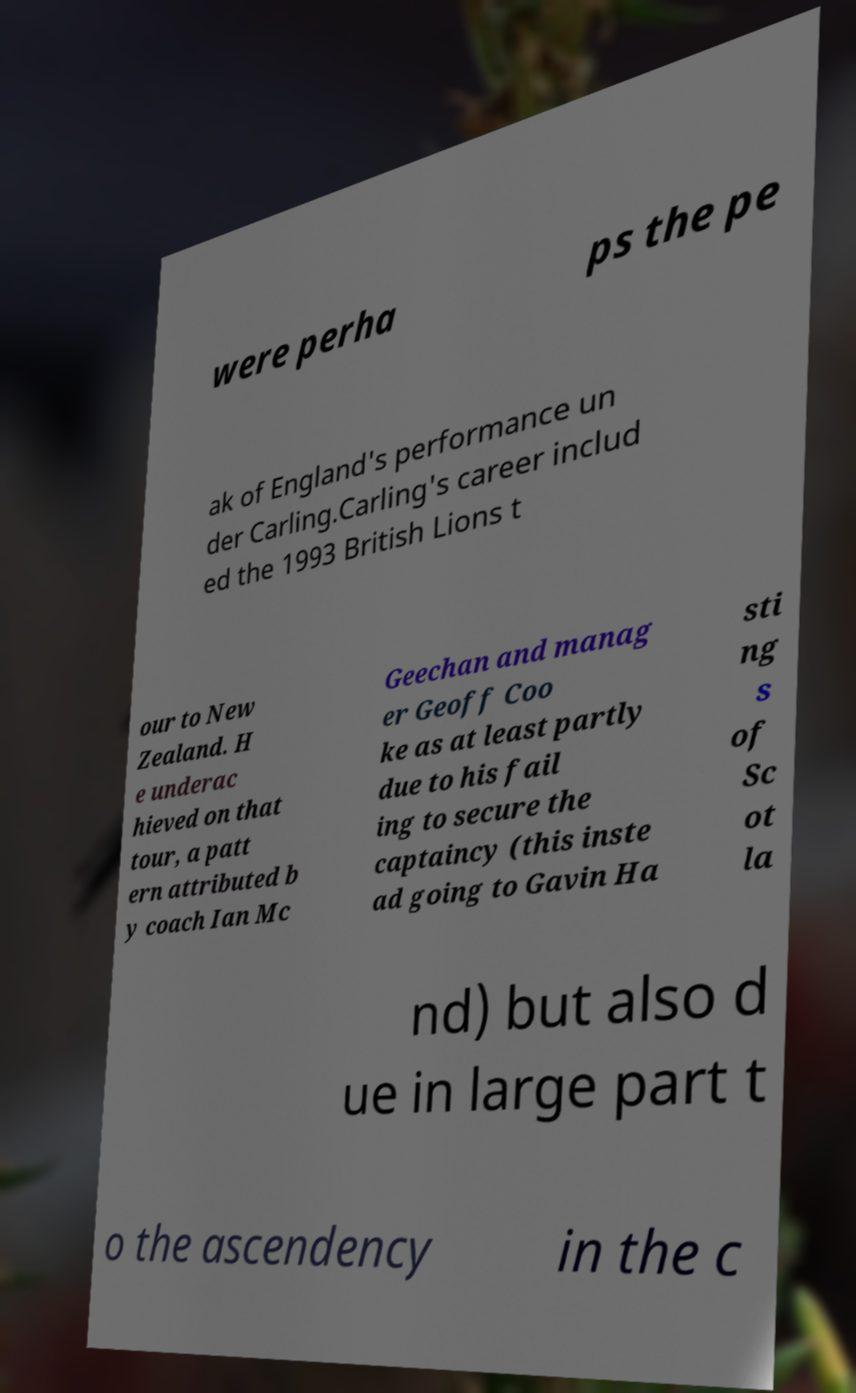For documentation purposes, I need the text within this image transcribed. Could you provide that? were perha ps the pe ak of England's performance un der Carling.Carling's career includ ed the 1993 British Lions t our to New Zealand. H e underac hieved on that tour, a patt ern attributed b y coach Ian Mc Geechan and manag er Geoff Coo ke as at least partly due to his fail ing to secure the captaincy (this inste ad going to Gavin Ha sti ng s of Sc ot la nd) but also d ue in large part t o the ascendency in the c 